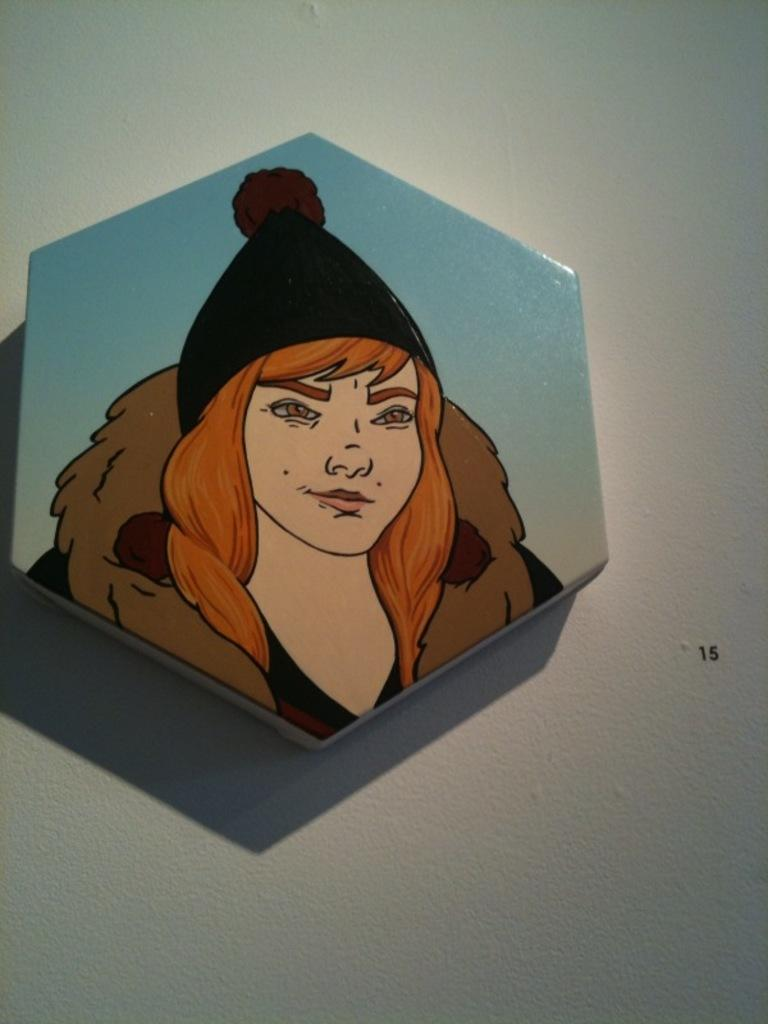What is present on the wall in the image? There is a frame on the wall. What is inside the frame? The frame contains a painting. What is the subject of the painting? The painting depicts a lady. How many oranges are on the lady's head in the painting? There are no oranges present in the image, and the lady in the painting does not have any oranges on her head. 